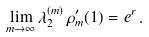<formula> <loc_0><loc_0><loc_500><loc_500>\lim _ { m \rightarrow \infty } \lambda _ { 2 } ^ { ( m ) } \, \rho ^ { \prime } _ { m } ( 1 ) = e ^ { r } \, .</formula> 